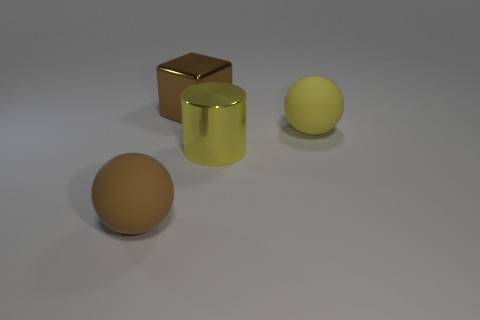What number of brown things are metallic things or big metallic blocks?
Offer a terse response. 1. Is the number of brown metallic things that are right of the large yellow matte thing the same as the number of large matte objects behind the cylinder?
Make the answer very short. No. There is a matte sphere in front of the ball on the right side of the large metallic thing in front of the big brown cube; what color is it?
Give a very brief answer. Brown. Are there any other things that are the same color as the large metal block?
Ensure brevity in your answer.  Yes. The big matte object that is the same color as the large shiny cylinder is what shape?
Ensure brevity in your answer.  Sphere. What shape is the metallic object that is the same size as the cube?
Ensure brevity in your answer.  Cylinder. Are the large brown thing that is in front of the brown shiny block and the big yellow thing on the right side of the large yellow metal object made of the same material?
Provide a succinct answer. Yes. The large cylinder in front of the large matte ball that is behind the big brown ball is made of what material?
Ensure brevity in your answer.  Metal. Do the big brown thing that is in front of the large shiny cube and the yellow thing that is behind the cylinder have the same shape?
Offer a terse response. Yes. There is a large brown thing that is behind the big brown ball; are there any yellow matte balls in front of it?
Your response must be concise. Yes. 